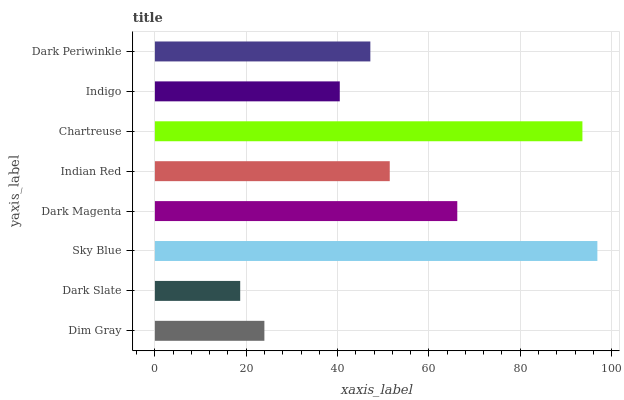Is Dark Slate the minimum?
Answer yes or no. Yes. Is Sky Blue the maximum?
Answer yes or no. Yes. Is Sky Blue the minimum?
Answer yes or no. No. Is Dark Slate the maximum?
Answer yes or no. No. Is Sky Blue greater than Dark Slate?
Answer yes or no. Yes. Is Dark Slate less than Sky Blue?
Answer yes or no. Yes. Is Dark Slate greater than Sky Blue?
Answer yes or no. No. Is Sky Blue less than Dark Slate?
Answer yes or no. No. Is Indian Red the high median?
Answer yes or no. Yes. Is Dark Periwinkle the low median?
Answer yes or no. Yes. Is Chartreuse the high median?
Answer yes or no. No. Is Chartreuse the low median?
Answer yes or no. No. 